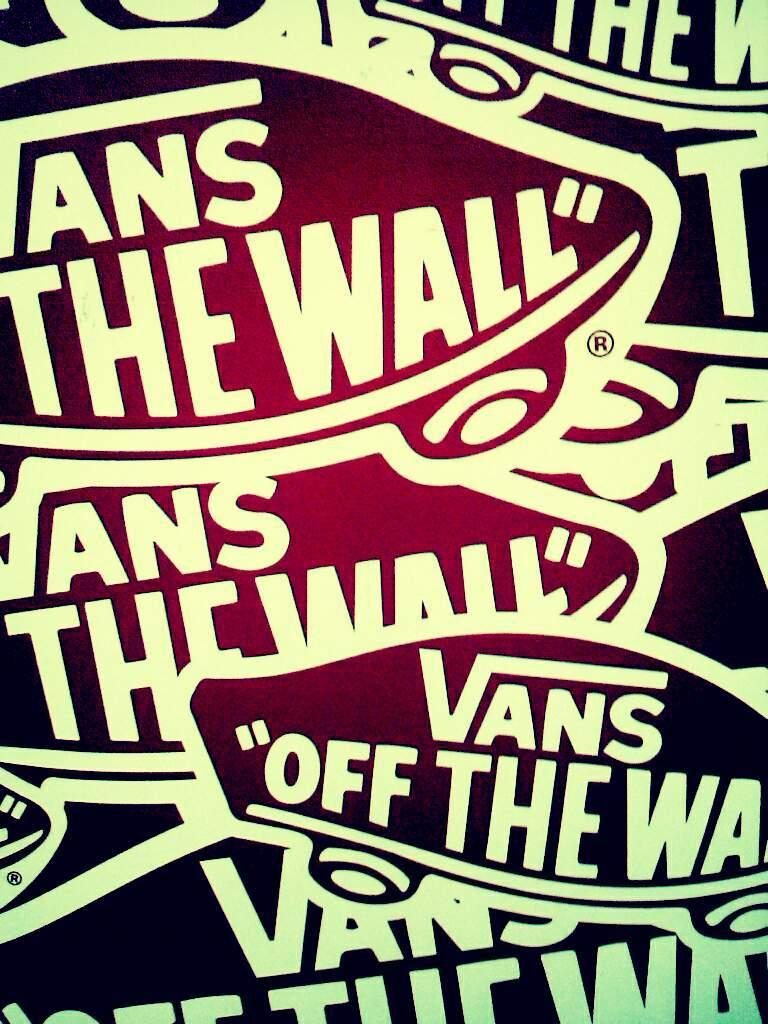Provide a one-sentence caption for the provided image. Multiple stickers of "Vans Off the Wall" crossing over one another. 